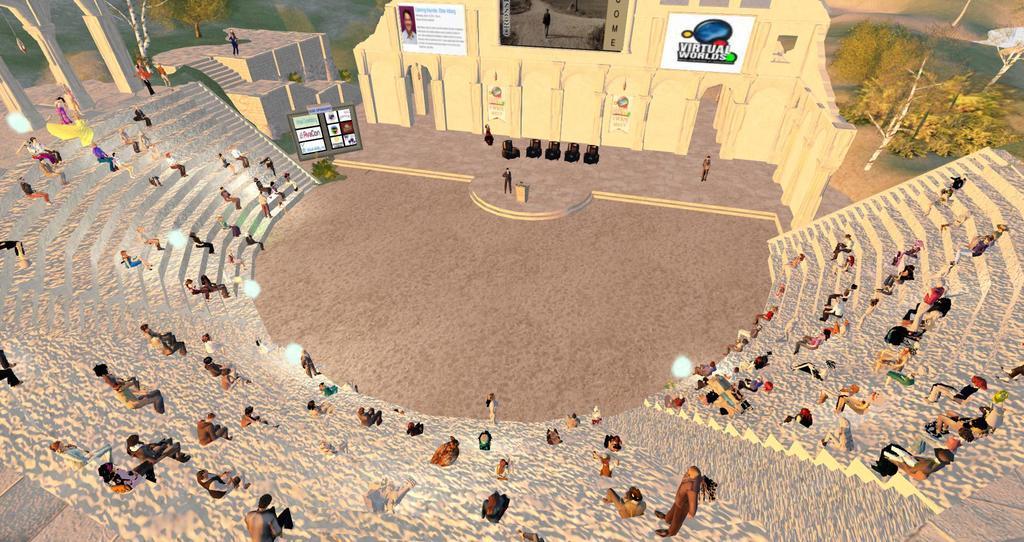Please provide a concise description of this image. In this image I can see stairs surrounding an open ground and people sitting on the stage. I can see three people standing on the stage, I can see some chairs, pillars, banners, boards and a screen. This is an animated image. I can see trees in the top left and right corners. 